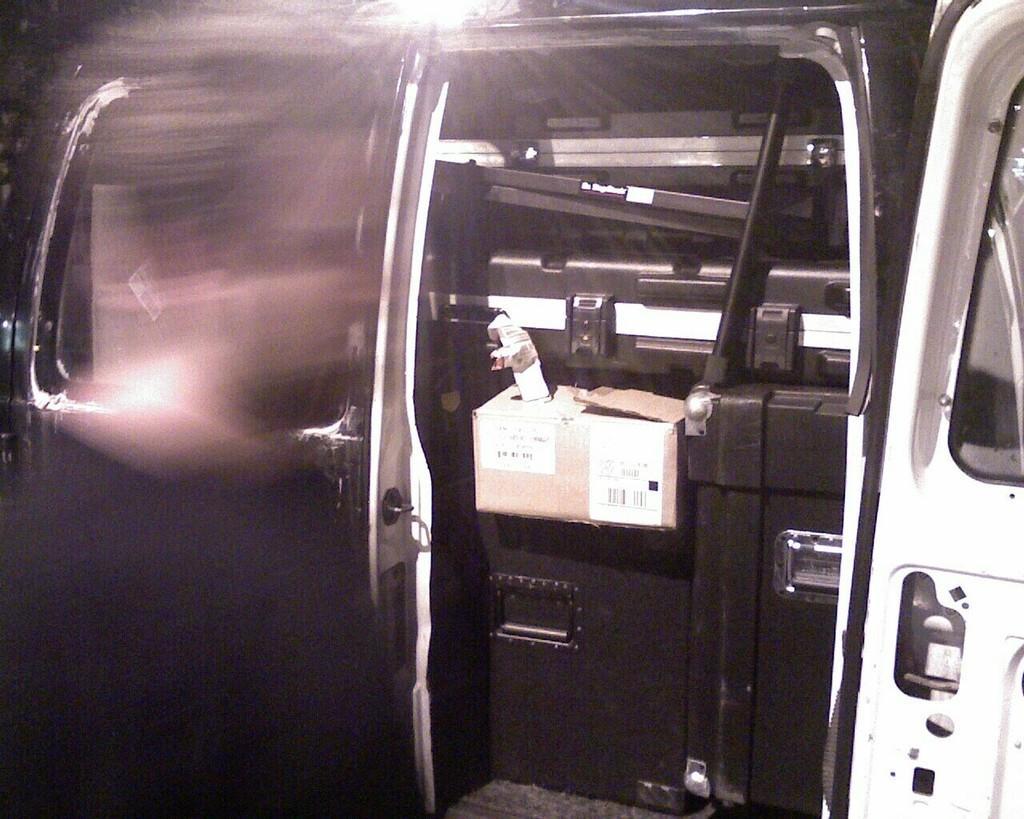In one or two sentences, can you explain what this image depicts? In this image there is a vehicle, in which there are tool boxes, on top of it there are card board box and there are door visible in the middle, at the top there is the light focus. 